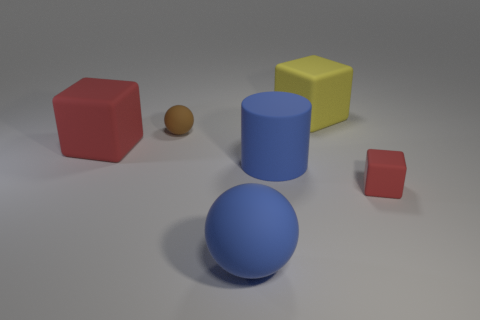Can you describe the sizes of the objects relative to each other? Certainly, relative to one another, we have a large blue sphere and a red cube of substantial size, followed by a smaller yet still sizeable blue cylinder and yellow cube. There is also a small red cube and a tiny brown ball that is the smallest object in the scene. 